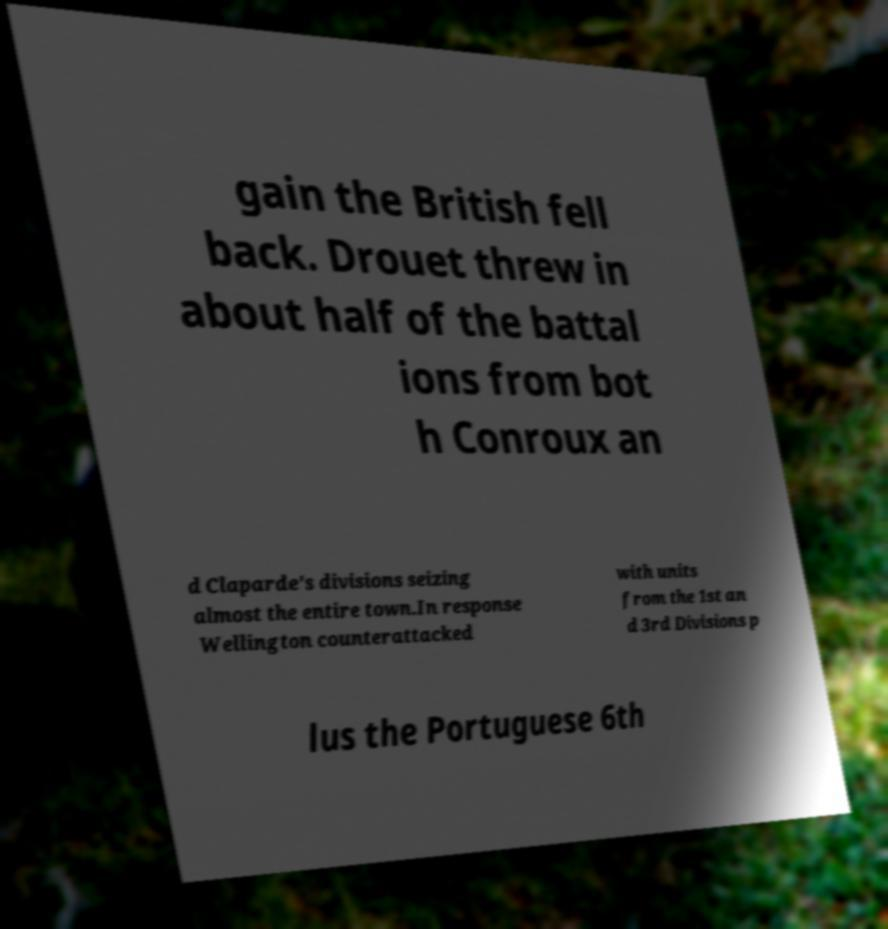Could you assist in decoding the text presented in this image and type it out clearly? gain the British fell back. Drouet threw in about half of the battal ions from bot h Conroux an d Claparde's divisions seizing almost the entire town.In response Wellington counterattacked with units from the 1st an d 3rd Divisions p lus the Portuguese 6th 